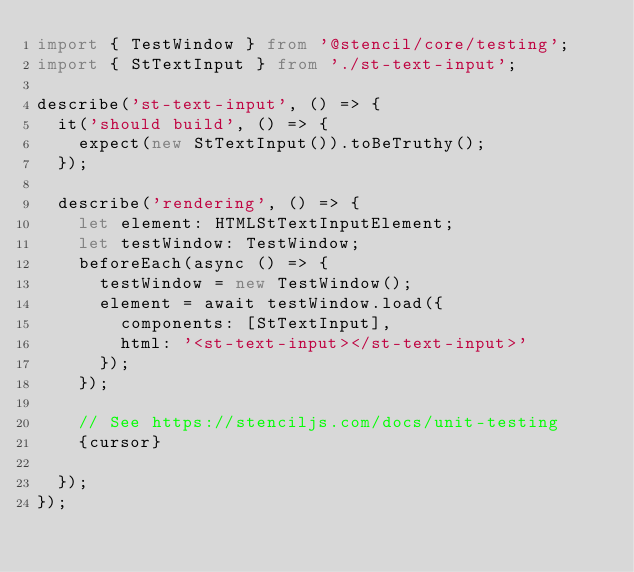Convert code to text. <code><loc_0><loc_0><loc_500><loc_500><_TypeScript_>import { TestWindow } from '@stencil/core/testing';
import { StTextInput } from './st-text-input';

describe('st-text-input', () => {
  it('should build', () => {
    expect(new StTextInput()).toBeTruthy();
  });

  describe('rendering', () => {
    let element: HTMLStTextInputElement;
    let testWindow: TestWindow;
    beforeEach(async () => {
      testWindow = new TestWindow();
      element = await testWindow.load({
        components: [StTextInput],
        html: '<st-text-input></st-text-input>'
      });
    });

    // See https://stenciljs.com/docs/unit-testing
    {cursor}

  });
});
</code> 